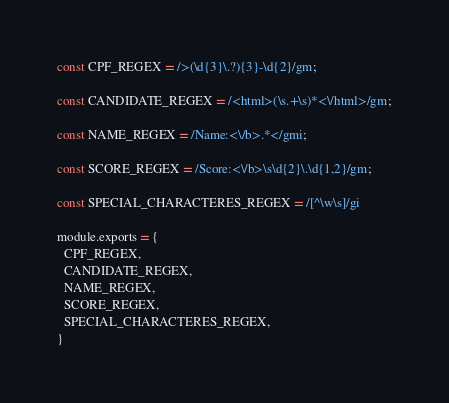Convert code to text. <code><loc_0><loc_0><loc_500><loc_500><_JavaScript_>const CPF_REGEX = />(\d{3}\.?){3}-\d{2}/gm;

const CANDIDATE_REGEX = /<html>(\s.+\s)*<\/html>/gm;

const NAME_REGEX = /Name:<\/b>.*</gmi;

const SCORE_REGEX = /Score:<\/b>\s\d{2}\.\d{1,2}/gm;

const SPECIAL_CHARACTERES_REGEX = /[^\w\s]/gi

module.exports = {
  CPF_REGEX,
  CANDIDATE_REGEX,
  NAME_REGEX,
  SCORE_REGEX,
  SPECIAL_CHARACTERES_REGEX,
}</code> 